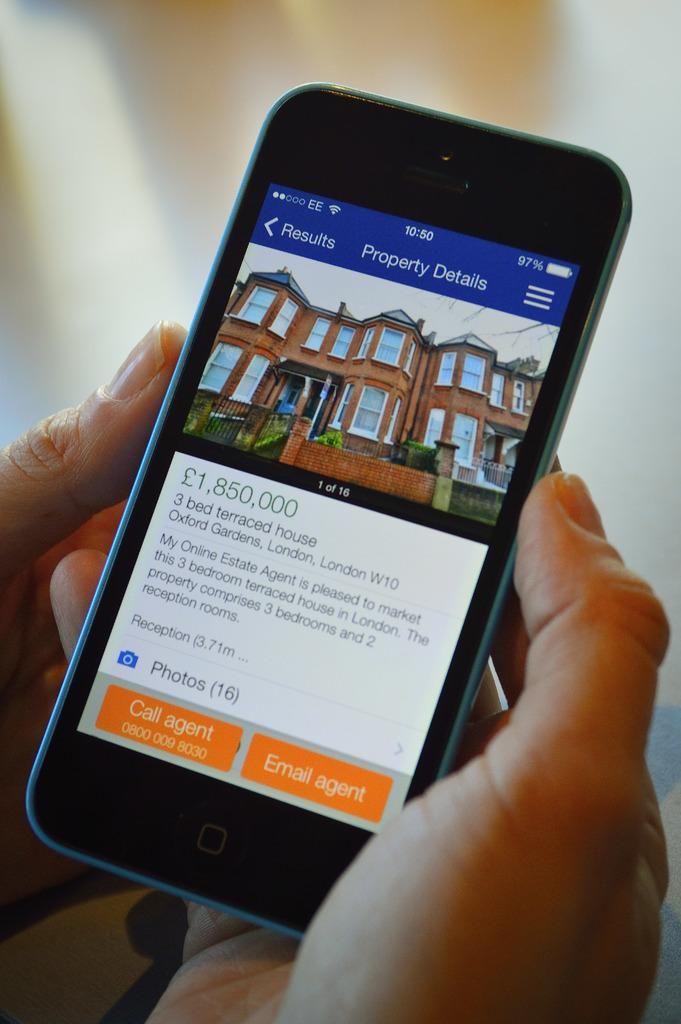What object is being held by a person in the image? There is a mobile in the image, and it is being held by a person. Can you describe the background of the image? The background of the image is blurry. What type of mitten is being used to hold the cannon in the image? There is no cannon or mitten present in the image. Can you describe the behavior of the rat in the image? There is no rat present in the image. 